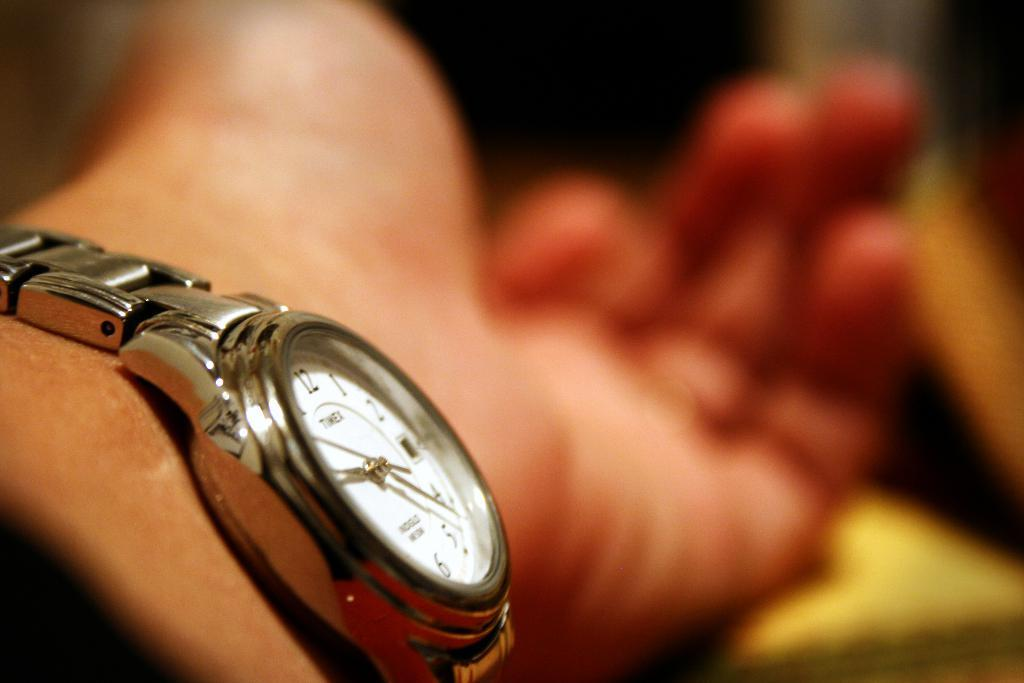What object is visible on a person's hand in the image? There is a wristwatch on a person's hand in the image. Can you describe the background of the image? The background of the image is blurred. What type of whistle can be heard in the image? There is no whistle present in the image, and therefore no sound can be heard. 